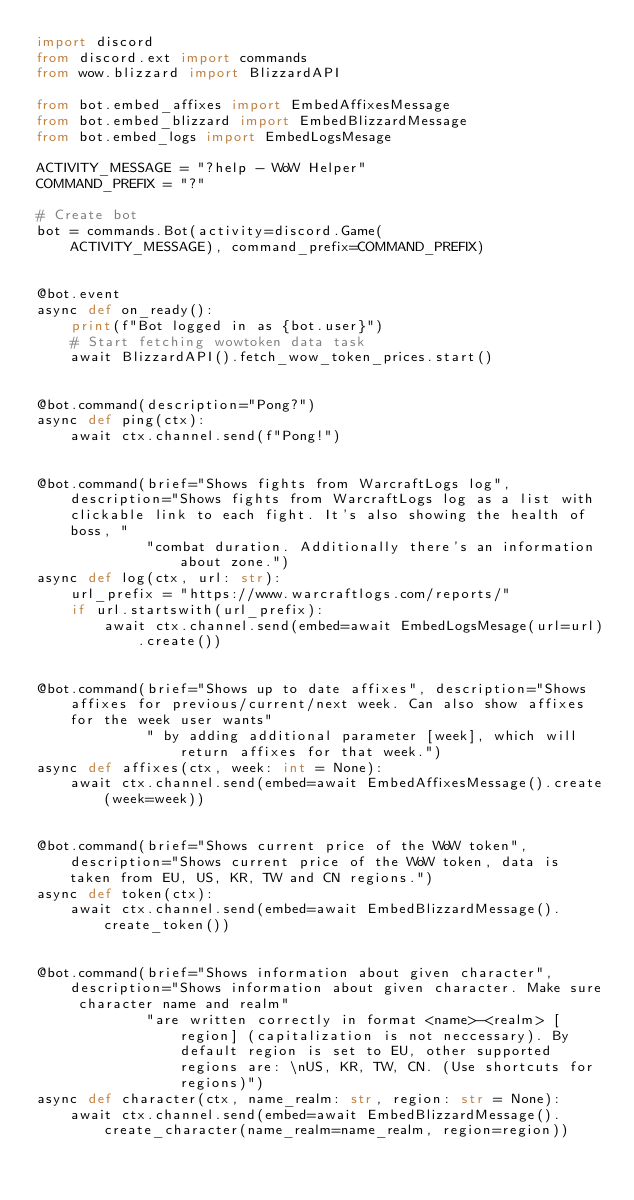<code> <loc_0><loc_0><loc_500><loc_500><_Python_>import discord
from discord.ext import commands
from wow.blizzard import BlizzardAPI

from bot.embed_affixes import EmbedAffixesMessage
from bot.embed_blizzard import EmbedBlizzardMessage
from bot.embed_logs import EmbedLogsMesage

ACTIVITY_MESSAGE = "?help - WoW Helper"
COMMAND_PREFIX = "?"

# Create bot
bot = commands.Bot(activity=discord.Game(
    ACTIVITY_MESSAGE), command_prefix=COMMAND_PREFIX)


@bot.event
async def on_ready():
    print(f"Bot logged in as {bot.user}")
    # Start fetching wowtoken data task
    await BlizzardAPI().fetch_wow_token_prices.start()


@bot.command(description="Pong?")
async def ping(ctx):
    await ctx.channel.send(f"Pong!")


@bot.command(brief="Shows fights from WarcraftLogs log", description="Shows fights from WarcraftLogs log as a list with clickable link to each fight. It's also showing the health of boss, "
             "combat duration. Additionally there's an information about zone.")
async def log(ctx, url: str):
    url_prefix = "https://www.warcraftlogs.com/reports/"
    if url.startswith(url_prefix):
        await ctx.channel.send(embed=await EmbedLogsMesage(url=url).create())


@bot.command(brief="Shows up to date affixes", description="Shows affixes for previous/current/next week. Can also show affixes for the week user wants"
             " by adding additional parameter [week], which will return affixes for that week.")
async def affixes(ctx, week: int = None):
    await ctx.channel.send(embed=await EmbedAffixesMessage().create(week=week))


@bot.command(brief="Shows current price of the WoW token", description="Shows current price of the WoW token, data is taken from EU, US, KR, TW and CN regions.")
async def token(ctx):
    await ctx.channel.send(embed=await EmbedBlizzardMessage().create_token())


@bot.command(brief="Shows information about given character", description="Shows information about given character. Make sure character name and realm"
             "are written correctly in format <name>-<realm> [region] (capitalization is not neccessary). By default region is set to EU, other supported regions are: \nUS, KR, TW, CN. (Use shortcuts for regions)")
async def character(ctx, name_realm: str, region: str = None):
    await ctx.channel.send(embed=await EmbedBlizzardMessage().create_character(name_realm=name_realm, region=region))
</code> 